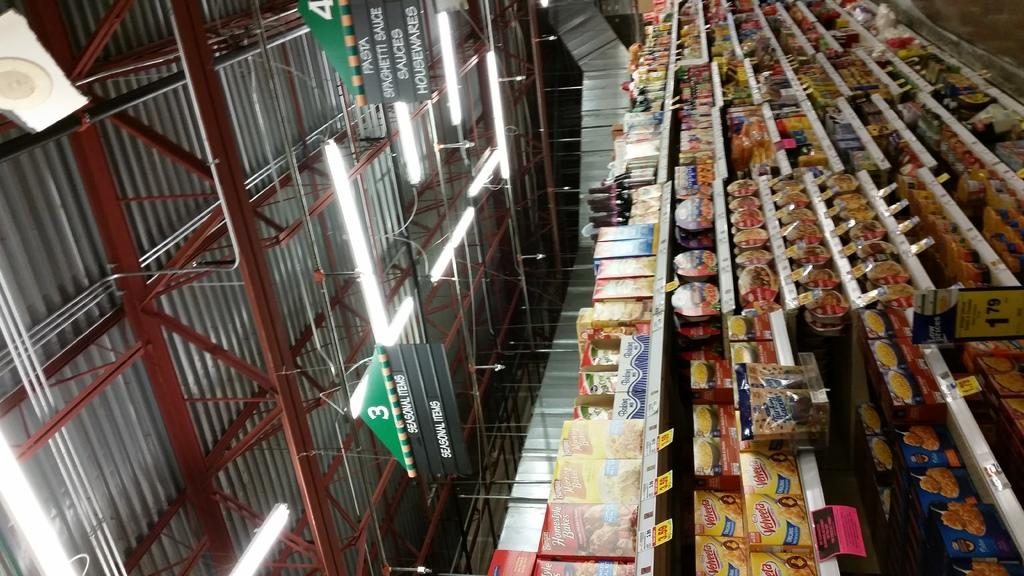<image>
Give a short and clear explanation of the subsequent image. A view of a grocery store aisle that sells pasta and sauces 